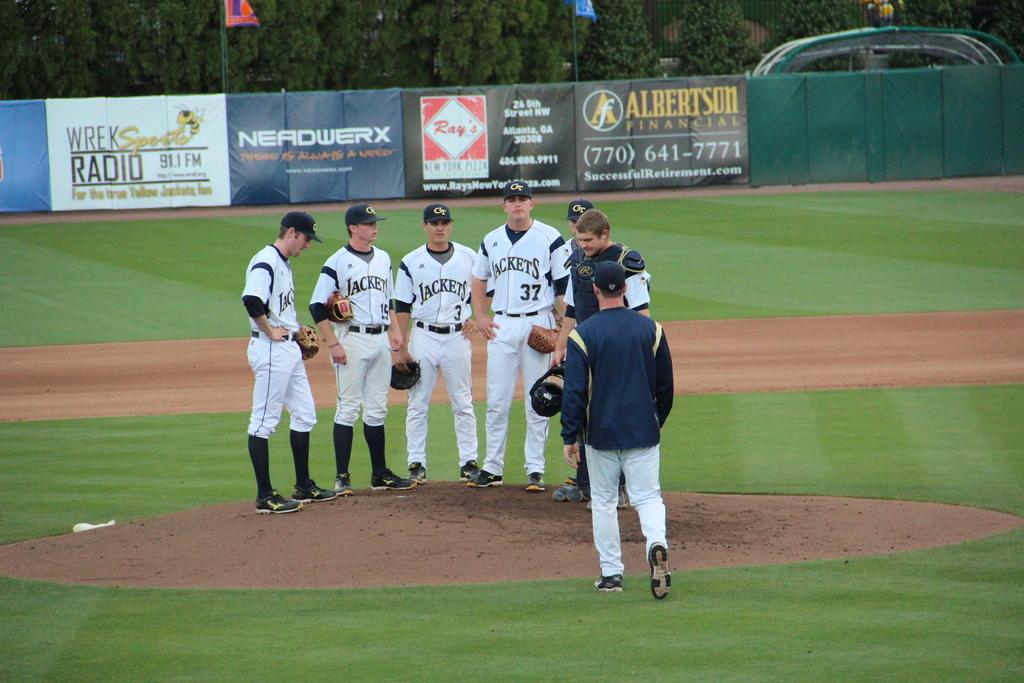<image>
Relay a brief, clear account of the picture shown. Six Jackets baseball players stand on the pitchers mound. 